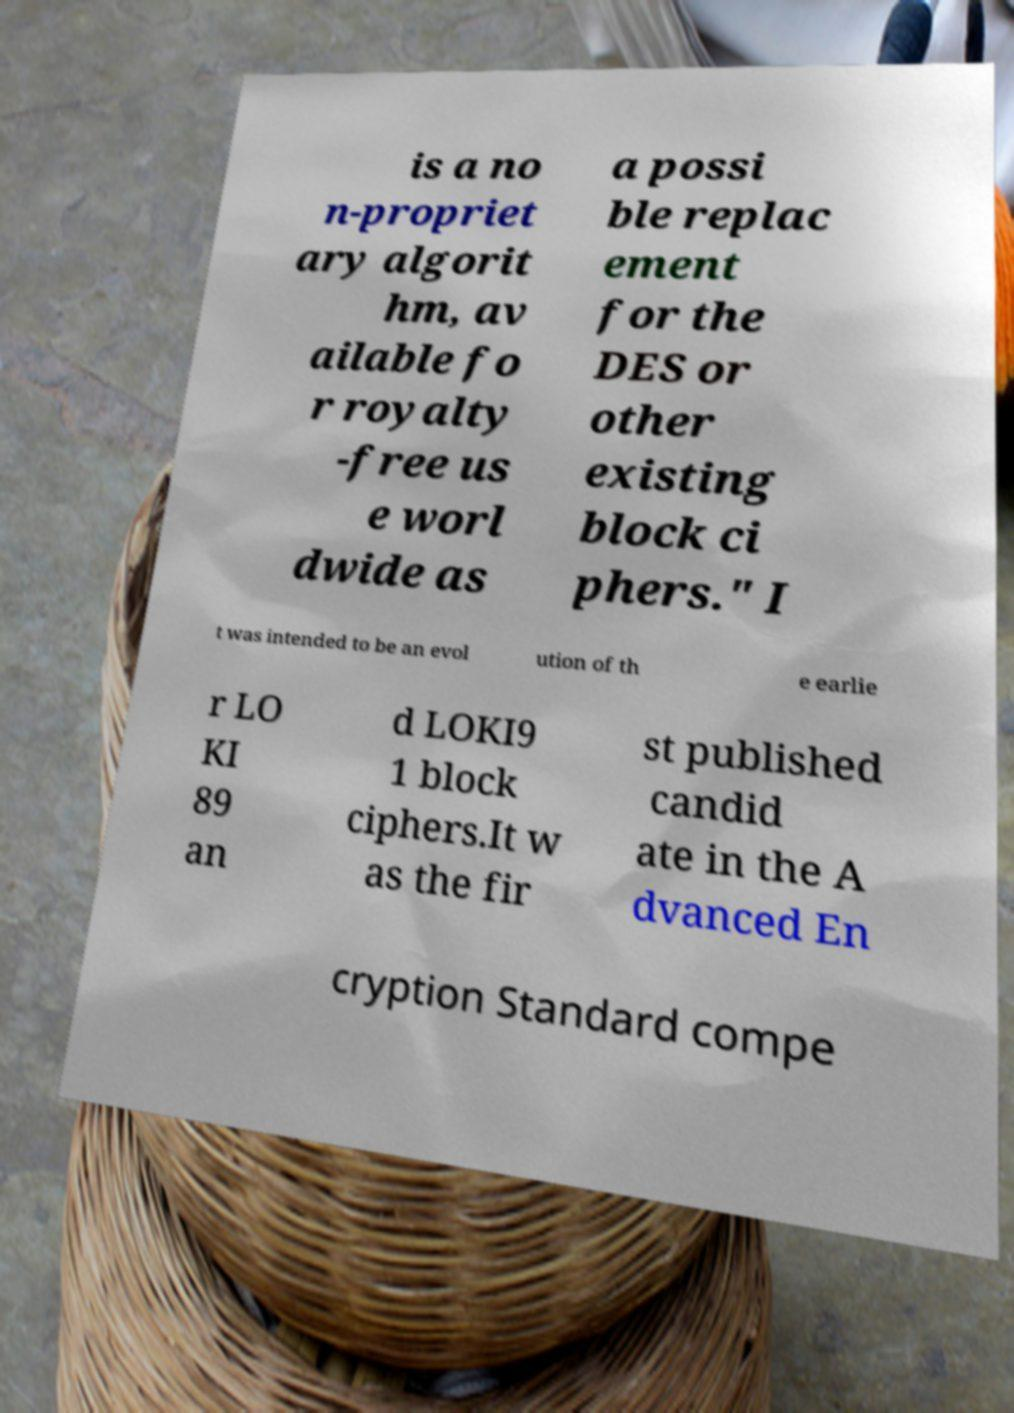For documentation purposes, I need the text within this image transcribed. Could you provide that? is a no n-propriet ary algorit hm, av ailable fo r royalty -free us e worl dwide as a possi ble replac ement for the DES or other existing block ci phers." I t was intended to be an evol ution of th e earlie r LO KI 89 an d LOKI9 1 block ciphers.It w as the fir st published candid ate in the A dvanced En cryption Standard compe 